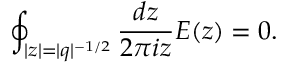Convert formula to latex. <formula><loc_0><loc_0><loc_500><loc_500>\oint _ { | z | = | q | ^ { - 1 / 2 } } \frac { d z } { 2 \pi i z } E ( z ) = 0 .</formula> 